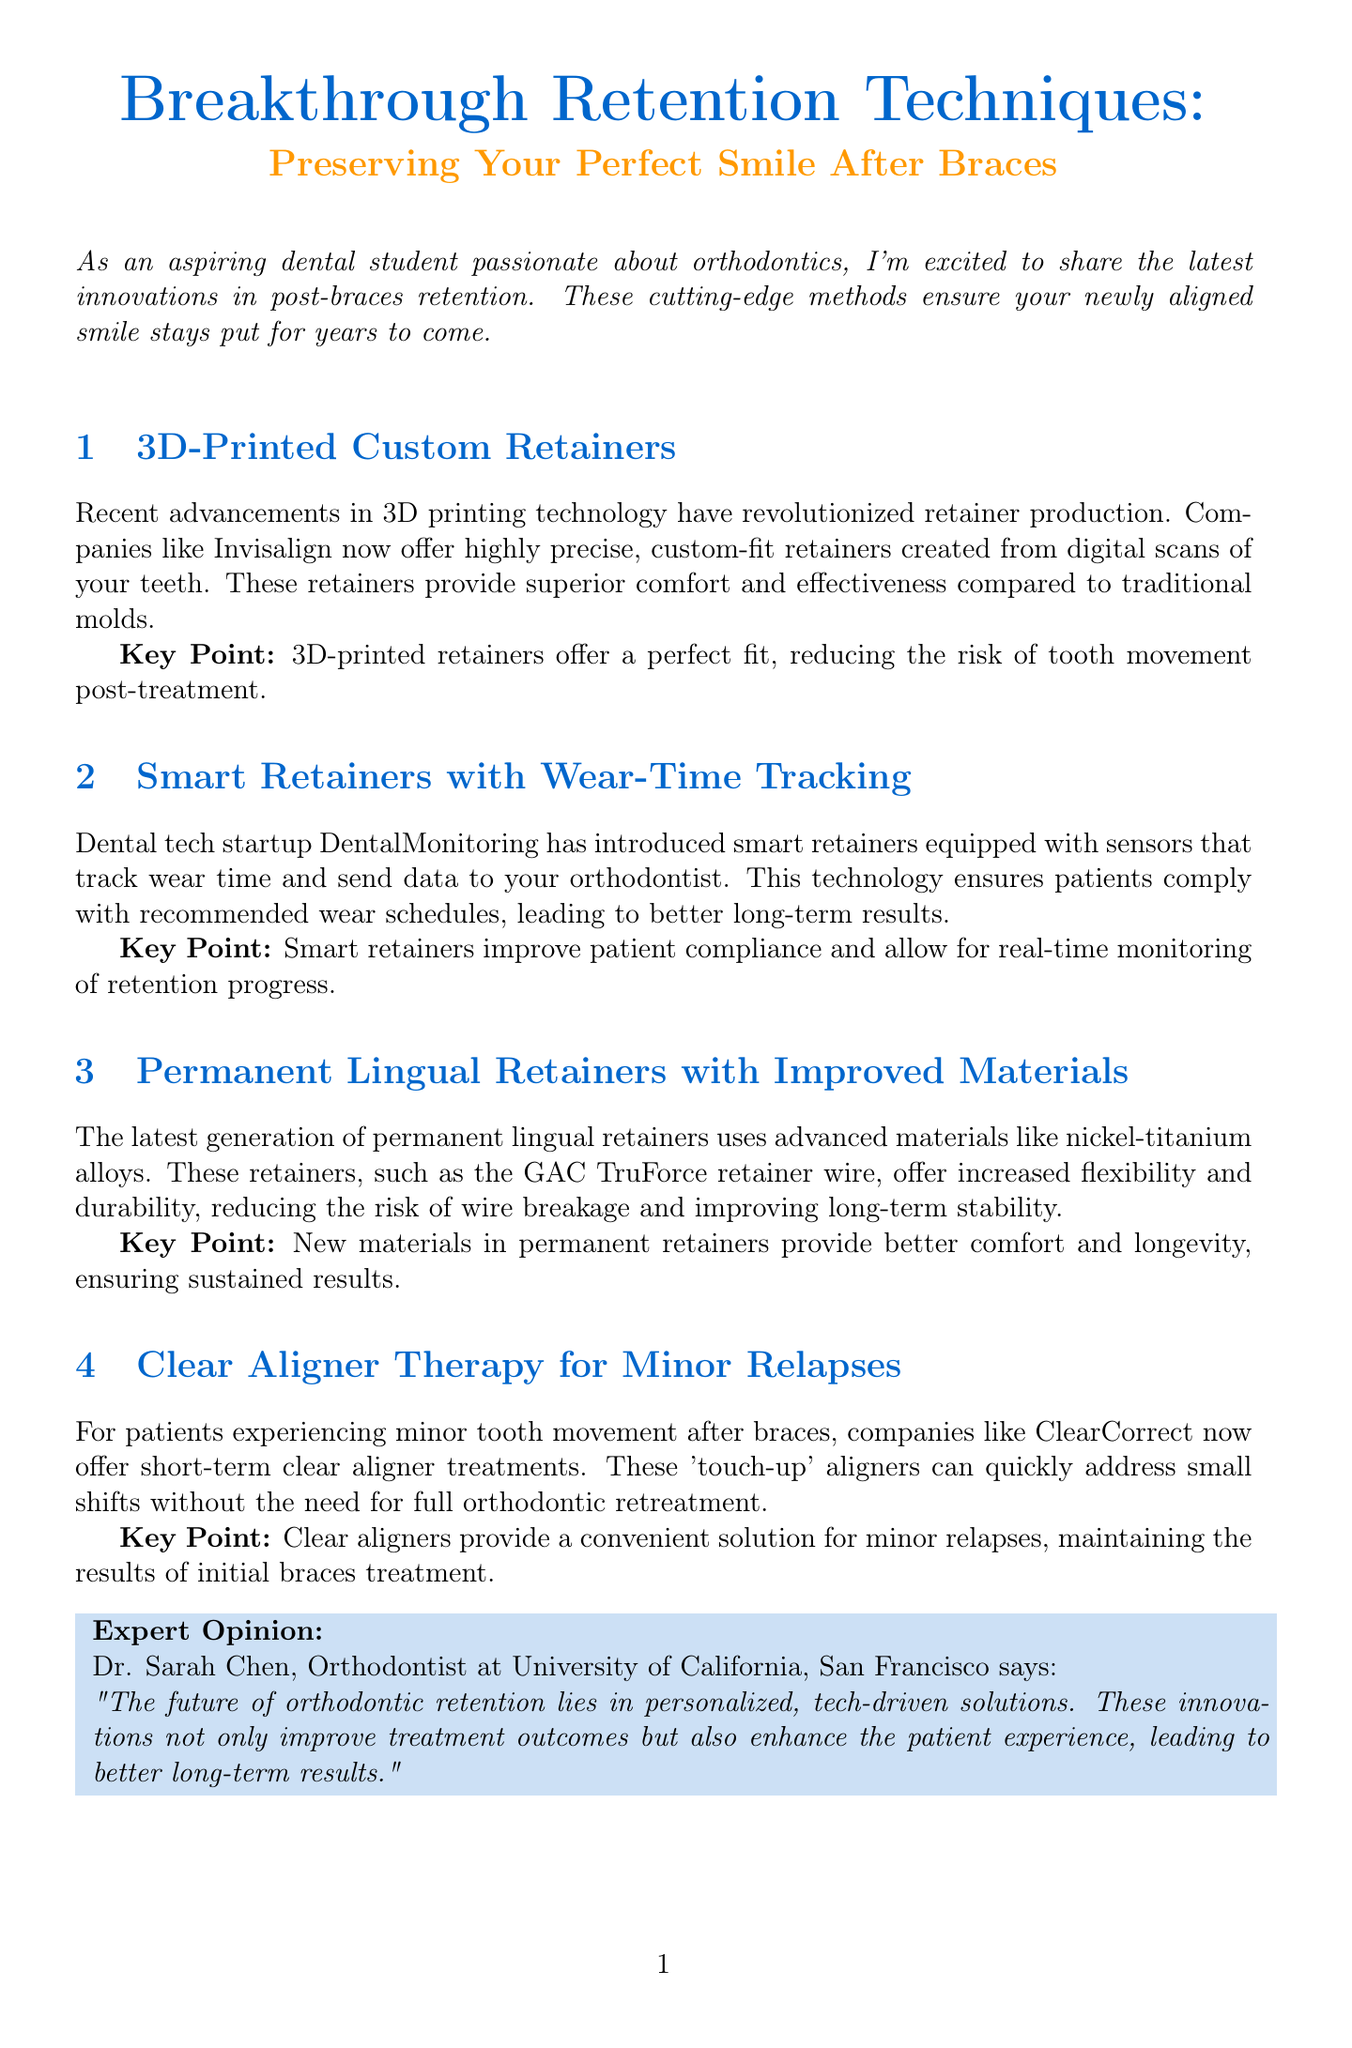What is the title of the newsletter? The title is prominently featured at the start of the document, indicating the focus on retention techniques after braces.
Answer: Breakthrough Retention Techniques: Preserving Your Perfect Smile After Braces Who is the expert quoted in the newsletter? The expert opinion section provides the name and title of the orthodontist who shares insights on the future of orthodontic retention.
Answer: Dr. Sarah Chen What type of retainers does Invisalign offer? The content mentions that Invisalign now offers precision custom-fit retainers, which are made using digital technology.
Answer: 3D-Printed Custom Retainers What technology is used in smart retainers? The section on smart retainers describes their capability to track wear time, which enhances patient compliance.
Answer: Sensors What material is used in the latest permanent lingual retainers? The section highlights advancements in materials for lingual retainers, specifically naming an alloy.
Answer: Nickel-titanium alloys How do clear aligners help post-braces? The clear aligner section outlines their use for addressing minor tooth movements, ensuring the results of orthodontic treatment.
Answer: Touch-up aligners What is a key benefit of 3D-printed retainers? The key point for 3D-printed retainers stresses their ability to fit perfectly, impacting post-treatment tooth stability.
Answer: Perfect fit What does Michael Rodriguez prefer over traditional retainers? The patient testimonial reflects his experience switching to a different type of retainer, emphasizing comfort.
Answer: 3D-printed ones 